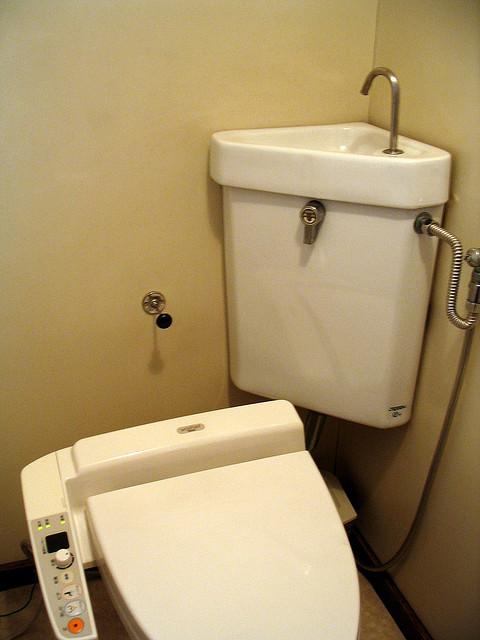Is this a American style toilet?
Keep it brief. No. What room would this be in?
Keep it brief. Bathroom. Where are the green indicator lights?
Write a very short answer. Toilet. Does the sink have an overflow orifice?
Quick response, please. Yes. 